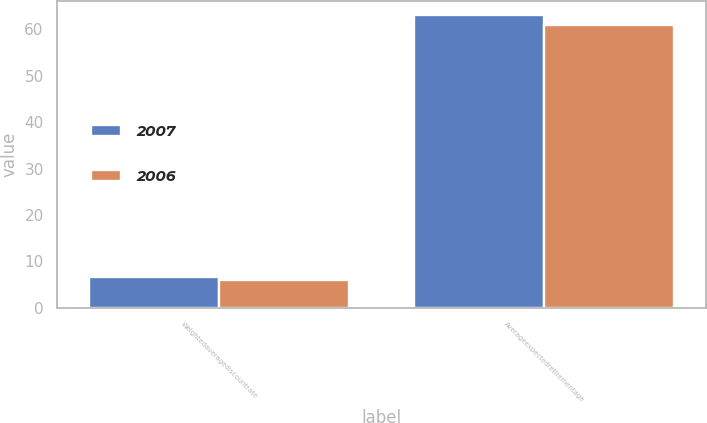Convert chart to OTSL. <chart><loc_0><loc_0><loc_500><loc_500><stacked_bar_chart><ecel><fcel>Weightedaveragediscountrate<fcel>Averageexpectedretirementage<nl><fcel>2007<fcel>6.65<fcel>63<nl><fcel>2006<fcel>6<fcel>61<nl></chart> 